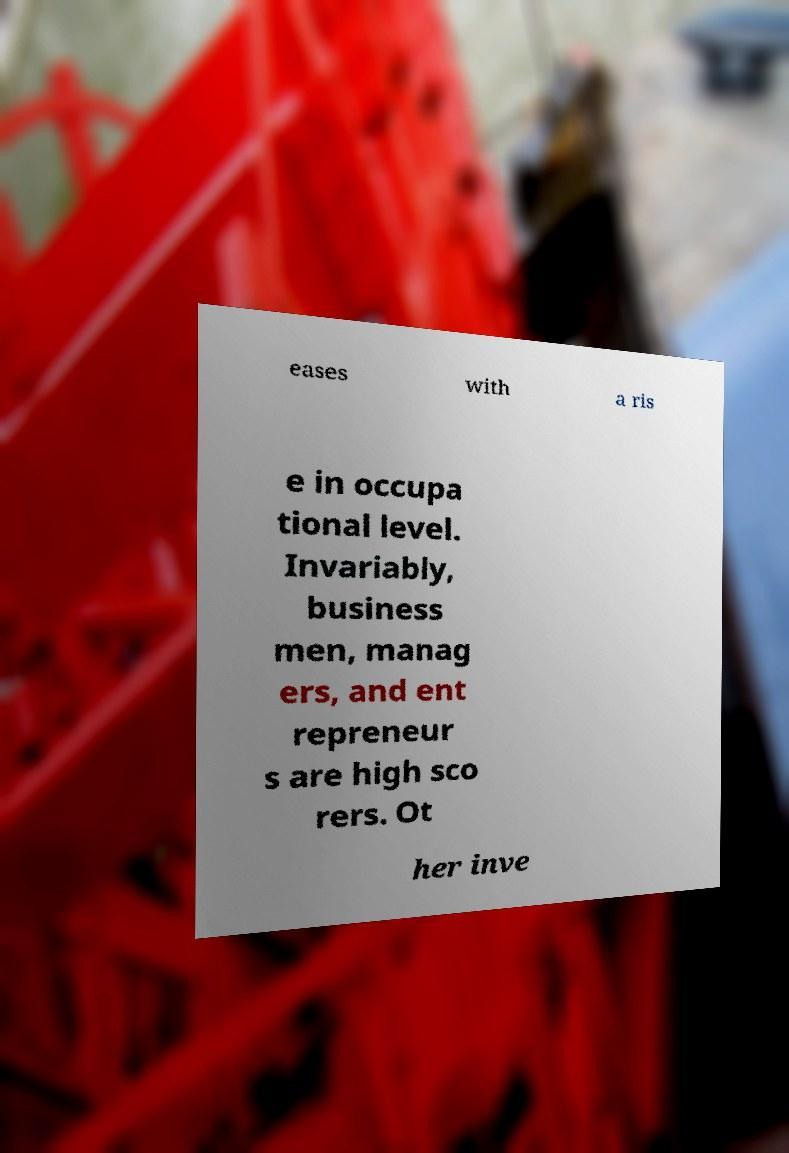For documentation purposes, I need the text within this image transcribed. Could you provide that? eases with a ris e in occupa tional level. Invariably, business men, manag ers, and ent repreneur s are high sco rers. Ot her inve 